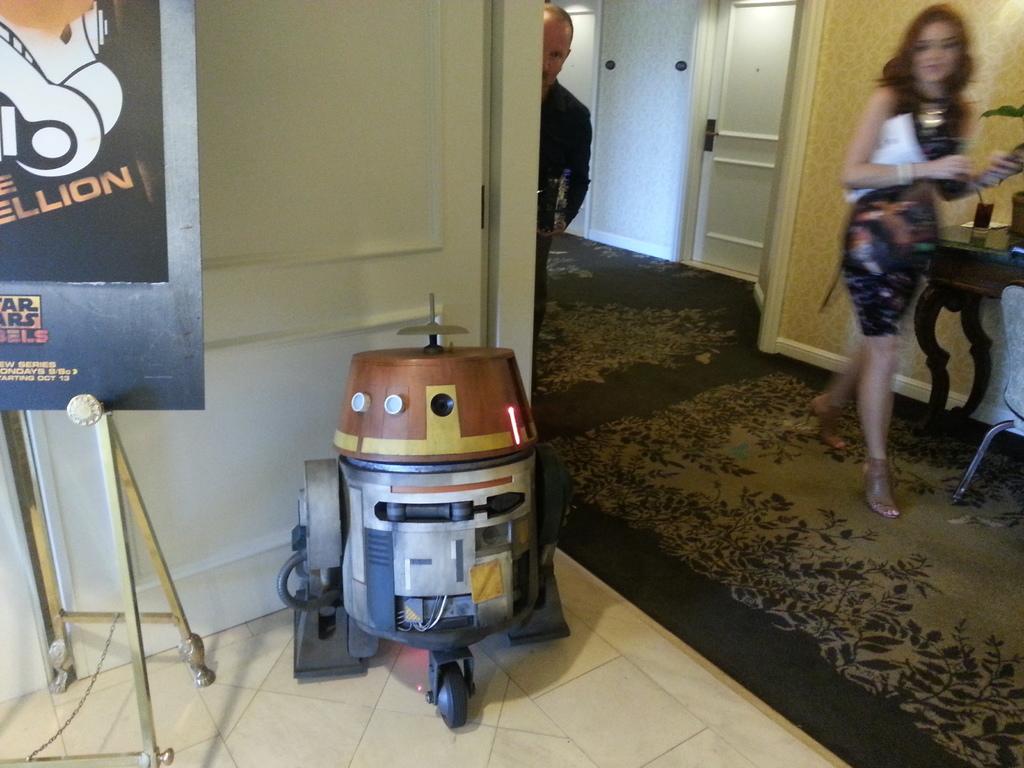Is that a star wars poster?
Make the answer very short. Yes. 